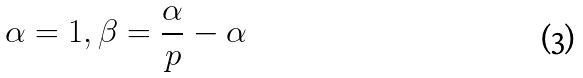<formula> <loc_0><loc_0><loc_500><loc_500>\alpha = 1 , \beta = \frac { \alpha } { p } - \alpha</formula> 